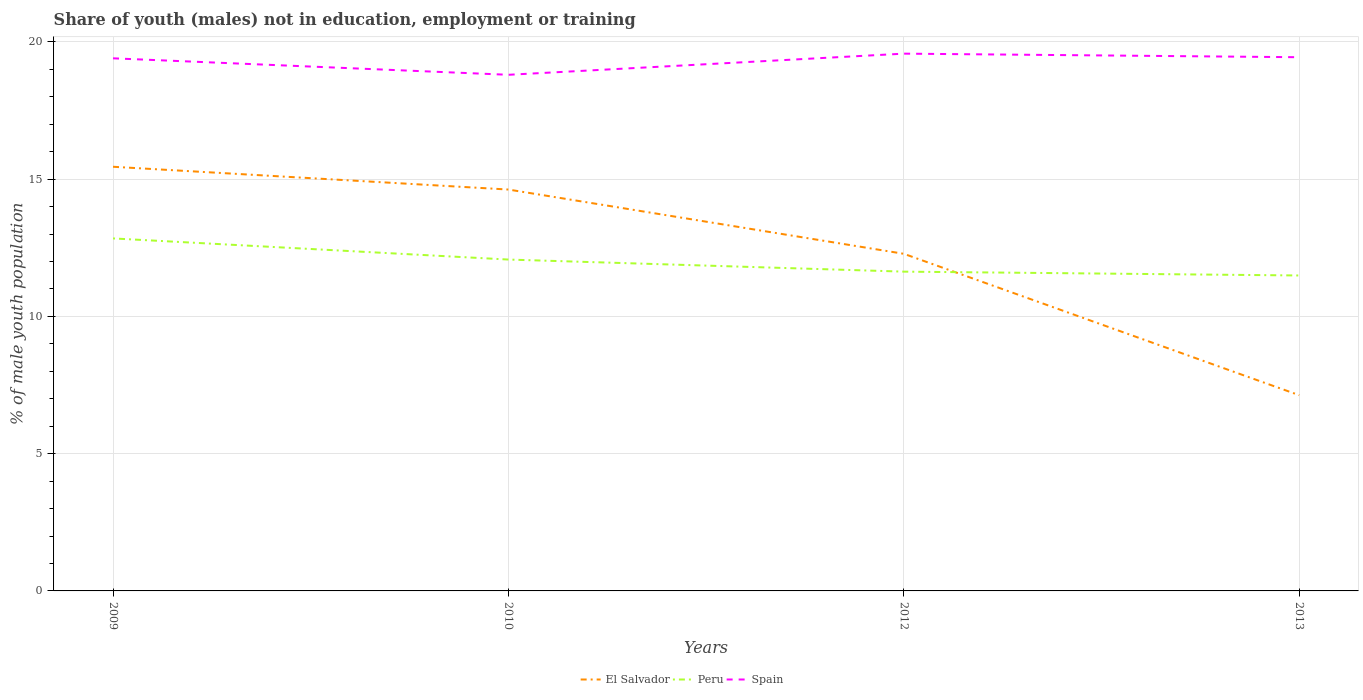How many different coloured lines are there?
Your response must be concise. 3. Is the number of lines equal to the number of legend labels?
Your answer should be compact. Yes. Across all years, what is the maximum percentage of unemployed males population in in El Salvador?
Your answer should be compact. 7.13. What is the total percentage of unemployed males population in in Spain in the graph?
Offer a terse response. -0.04. What is the difference between the highest and the second highest percentage of unemployed males population in in El Salvador?
Offer a very short reply. 8.32. What is the difference between the highest and the lowest percentage of unemployed males population in in Peru?
Make the answer very short. 2. Is the percentage of unemployed males population in in Spain strictly greater than the percentage of unemployed males population in in El Salvador over the years?
Provide a short and direct response. No. What is the difference between two consecutive major ticks on the Y-axis?
Provide a short and direct response. 5. Are the values on the major ticks of Y-axis written in scientific E-notation?
Your response must be concise. No. Does the graph contain any zero values?
Give a very brief answer. No. What is the title of the graph?
Offer a terse response. Share of youth (males) not in education, employment or training. Does "France" appear as one of the legend labels in the graph?
Your answer should be compact. No. What is the label or title of the Y-axis?
Your answer should be very brief. % of male youth population. What is the % of male youth population of El Salvador in 2009?
Your answer should be very brief. 15.45. What is the % of male youth population of Peru in 2009?
Provide a short and direct response. 12.84. What is the % of male youth population in Spain in 2009?
Your answer should be compact. 19.4. What is the % of male youth population of El Salvador in 2010?
Offer a terse response. 14.62. What is the % of male youth population of Peru in 2010?
Offer a very short reply. 12.07. What is the % of male youth population in Spain in 2010?
Provide a short and direct response. 18.8. What is the % of male youth population of El Salvador in 2012?
Provide a succinct answer. 12.28. What is the % of male youth population of Peru in 2012?
Your answer should be very brief. 11.63. What is the % of male youth population of Spain in 2012?
Your response must be concise. 19.57. What is the % of male youth population of El Salvador in 2013?
Offer a terse response. 7.13. What is the % of male youth population in Peru in 2013?
Your answer should be very brief. 11.49. What is the % of male youth population of Spain in 2013?
Offer a very short reply. 19.44. Across all years, what is the maximum % of male youth population of El Salvador?
Provide a succinct answer. 15.45. Across all years, what is the maximum % of male youth population in Peru?
Provide a succinct answer. 12.84. Across all years, what is the maximum % of male youth population of Spain?
Provide a succinct answer. 19.57. Across all years, what is the minimum % of male youth population of El Salvador?
Provide a short and direct response. 7.13. Across all years, what is the minimum % of male youth population of Peru?
Your answer should be very brief. 11.49. Across all years, what is the minimum % of male youth population in Spain?
Give a very brief answer. 18.8. What is the total % of male youth population of El Salvador in the graph?
Ensure brevity in your answer.  49.48. What is the total % of male youth population in Peru in the graph?
Ensure brevity in your answer.  48.03. What is the total % of male youth population in Spain in the graph?
Provide a short and direct response. 77.21. What is the difference between the % of male youth population in El Salvador in 2009 and that in 2010?
Make the answer very short. 0.83. What is the difference between the % of male youth population in Peru in 2009 and that in 2010?
Make the answer very short. 0.77. What is the difference between the % of male youth population of Spain in 2009 and that in 2010?
Your answer should be very brief. 0.6. What is the difference between the % of male youth population of El Salvador in 2009 and that in 2012?
Keep it short and to the point. 3.17. What is the difference between the % of male youth population in Peru in 2009 and that in 2012?
Keep it short and to the point. 1.21. What is the difference between the % of male youth population of Spain in 2009 and that in 2012?
Your answer should be compact. -0.17. What is the difference between the % of male youth population of El Salvador in 2009 and that in 2013?
Ensure brevity in your answer.  8.32. What is the difference between the % of male youth population in Peru in 2009 and that in 2013?
Offer a terse response. 1.35. What is the difference between the % of male youth population in Spain in 2009 and that in 2013?
Your answer should be very brief. -0.04. What is the difference between the % of male youth population in El Salvador in 2010 and that in 2012?
Give a very brief answer. 2.34. What is the difference between the % of male youth population in Peru in 2010 and that in 2012?
Provide a succinct answer. 0.44. What is the difference between the % of male youth population in Spain in 2010 and that in 2012?
Your response must be concise. -0.77. What is the difference between the % of male youth population in El Salvador in 2010 and that in 2013?
Provide a succinct answer. 7.49. What is the difference between the % of male youth population of Peru in 2010 and that in 2013?
Your response must be concise. 0.58. What is the difference between the % of male youth population of Spain in 2010 and that in 2013?
Ensure brevity in your answer.  -0.64. What is the difference between the % of male youth population in El Salvador in 2012 and that in 2013?
Provide a succinct answer. 5.15. What is the difference between the % of male youth population of Peru in 2012 and that in 2013?
Provide a succinct answer. 0.14. What is the difference between the % of male youth population in Spain in 2012 and that in 2013?
Your answer should be compact. 0.13. What is the difference between the % of male youth population of El Salvador in 2009 and the % of male youth population of Peru in 2010?
Give a very brief answer. 3.38. What is the difference between the % of male youth population in El Salvador in 2009 and the % of male youth population in Spain in 2010?
Keep it short and to the point. -3.35. What is the difference between the % of male youth population in Peru in 2009 and the % of male youth population in Spain in 2010?
Your answer should be compact. -5.96. What is the difference between the % of male youth population in El Salvador in 2009 and the % of male youth population in Peru in 2012?
Your response must be concise. 3.82. What is the difference between the % of male youth population in El Salvador in 2009 and the % of male youth population in Spain in 2012?
Your answer should be very brief. -4.12. What is the difference between the % of male youth population of Peru in 2009 and the % of male youth population of Spain in 2012?
Offer a terse response. -6.73. What is the difference between the % of male youth population of El Salvador in 2009 and the % of male youth population of Peru in 2013?
Ensure brevity in your answer.  3.96. What is the difference between the % of male youth population in El Salvador in 2009 and the % of male youth population in Spain in 2013?
Keep it short and to the point. -3.99. What is the difference between the % of male youth population in El Salvador in 2010 and the % of male youth population in Peru in 2012?
Your answer should be compact. 2.99. What is the difference between the % of male youth population of El Salvador in 2010 and the % of male youth population of Spain in 2012?
Ensure brevity in your answer.  -4.95. What is the difference between the % of male youth population in El Salvador in 2010 and the % of male youth population in Peru in 2013?
Provide a short and direct response. 3.13. What is the difference between the % of male youth population of El Salvador in 2010 and the % of male youth population of Spain in 2013?
Keep it short and to the point. -4.82. What is the difference between the % of male youth population in Peru in 2010 and the % of male youth population in Spain in 2013?
Offer a very short reply. -7.37. What is the difference between the % of male youth population in El Salvador in 2012 and the % of male youth population in Peru in 2013?
Give a very brief answer. 0.79. What is the difference between the % of male youth population of El Salvador in 2012 and the % of male youth population of Spain in 2013?
Offer a very short reply. -7.16. What is the difference between the % of male youth population in Peru in 2012 and the % of male youth population in Spain in 2013?
Keep it short and to the point. -7.81. What is the average % of male youth population in El Salvador per year?
Offer a terse response. 12.37. What is the average % of male youth population of Peru per year?
Ensure brevity in your answer.  12.01. What is the average % of male youth population of Spain per year?
Provide a succinct answer. 19.3. In the year 2009, what is the difference between the % of male youth population of El Salvador and % of male youth population of Peru?
Give a very brief answer. 2.61. In the year 2009, what is the difference between the % of male youth population in El Salvador and % of male youth population in Spain?
Provide a short and direct response. -3.95. In the year 2009, what is the difference between the % of male youth population in Peru and % of male youth population in Spain?
Provide a succinct answer. -6.56. In the year 2010, what is the difference between the % of male youth population of El Salvador and % of male youth population of Peru?
Provide a short and direct response. 2.55. In the year 2010, what is the difference between the % of male youth population in El Salvador and % of male youth population in Spain?
Give a very brief answer. -4.18. In the year 2010, what is the difference between the % of male youth population in Peru and % of male youth population in Spain?
Provide a short and direct response. -6.73. In the year 2012, what is the difference between the % of male youth population of El Salvador and % of male youth population of Peru?
Give a very brief answer. 0.65. In the year 2012, what is the difference between the % of male youth population in El Salvador and % of male youth population in Spain?
Your answer should be very brief. -7.29. In the year 2012, what is the difference between the % of male youth population of Peru and % of male youth population of Spain?
Offer a very short reply. -7.94. In the year 2013, what is the difference between the % of male youth population in El Salvador and % of male youth population in Peru?
Keep it short and to the point. -4.36. In the year 2013, what is the difference between the % of male youth population of El Salvador and % of male youth population of Spain?
Provide a succinct answer. -12.31. In the year 2013, what is the difference between the % of male youth population in Peru and % of male youth population in Spain?
Keep it short and to the point. -7.95. What is the ratio of the % of male youth population of El Salvador in 2009 to that in 2010?
Offer a very short reply. 1.06. What is the ratio of the % of male youth population of Peru in 2009 to that in 2010?
Provide a short and direct response. 1.06. What is the ratio of the % of male youth population of Spain in 2009 to that in 2010?
Provide a succinct answer. 1.03. What is the ratio of the % of male youth population in El Salvador in 2009 to that in 2012?
Your answer should be compact. 1.26. What is the ratio of the % of male youth population in Peru in 2009 to that in 2012?
Offer a very short reply. 1.1. What is the ratio of the % of male youth population in El Salvador in 2009 to that in 2013?
Provide a short and direct response. 2.17. What is the ratio of the % of male youth population of Peru in 2009 to that in 2013?
Your answer should be compact. 1.12. What is the ratio of the % of male youth population of El Salvador in 2010 to that in 2012?
Make the answer very short. 1.19. What is the ratio of the % of male youth population of Peru in 2010 to that in 2012?
Provide a succinct answer. 1.04. What is the ratio of the % of male youth population of Spain in 2010 to that in 2012?
Your answer should be very brief. 0.96. What is the ratio of the % of male youth population in El Salvador in 2010 to that in 2013?
Your answer should be very brief. 2.05. What is the ratio of the % of male youth population in Peru in 2010 to that in 2013?
Provide a short and direct response. 1.05. What is the ratio of the % of male youth population in Spain in 2010 to that in 2013?
Your answer should be compact. 0.97. What is the ratio of the % of male youth population in El Salvador in 2012 to that in 2013?
Provide a succinct answer. 1.72. What is the ratio of the % of male youth population in Peru in 2012 to that in 2013?
Keep it short and to the point. 1.01. What is the difference between the highest and the second highest % of male youth population of El Salvador?
Ensure brevity in your answer.  0.83. What is the difference between the highest and the second highest % of male youth population of Peru?
Make the answer very short. 0.77. What is the difference between the highest and the second highest % of male youth population of Spain?
Ensure brevity in your answer.  0.13. What is the difference between the highest and the lowest % of male youth population in El Salvador?
Your answer should be very brief. 8.32. What is the difference between the highest and the lowest % of male youth population in Peru?
Provide a succinct answer. 1.35. What is the difference between the highest and the lowest % of male youth population in Spain?
Your answer should be compact. 0.77. 